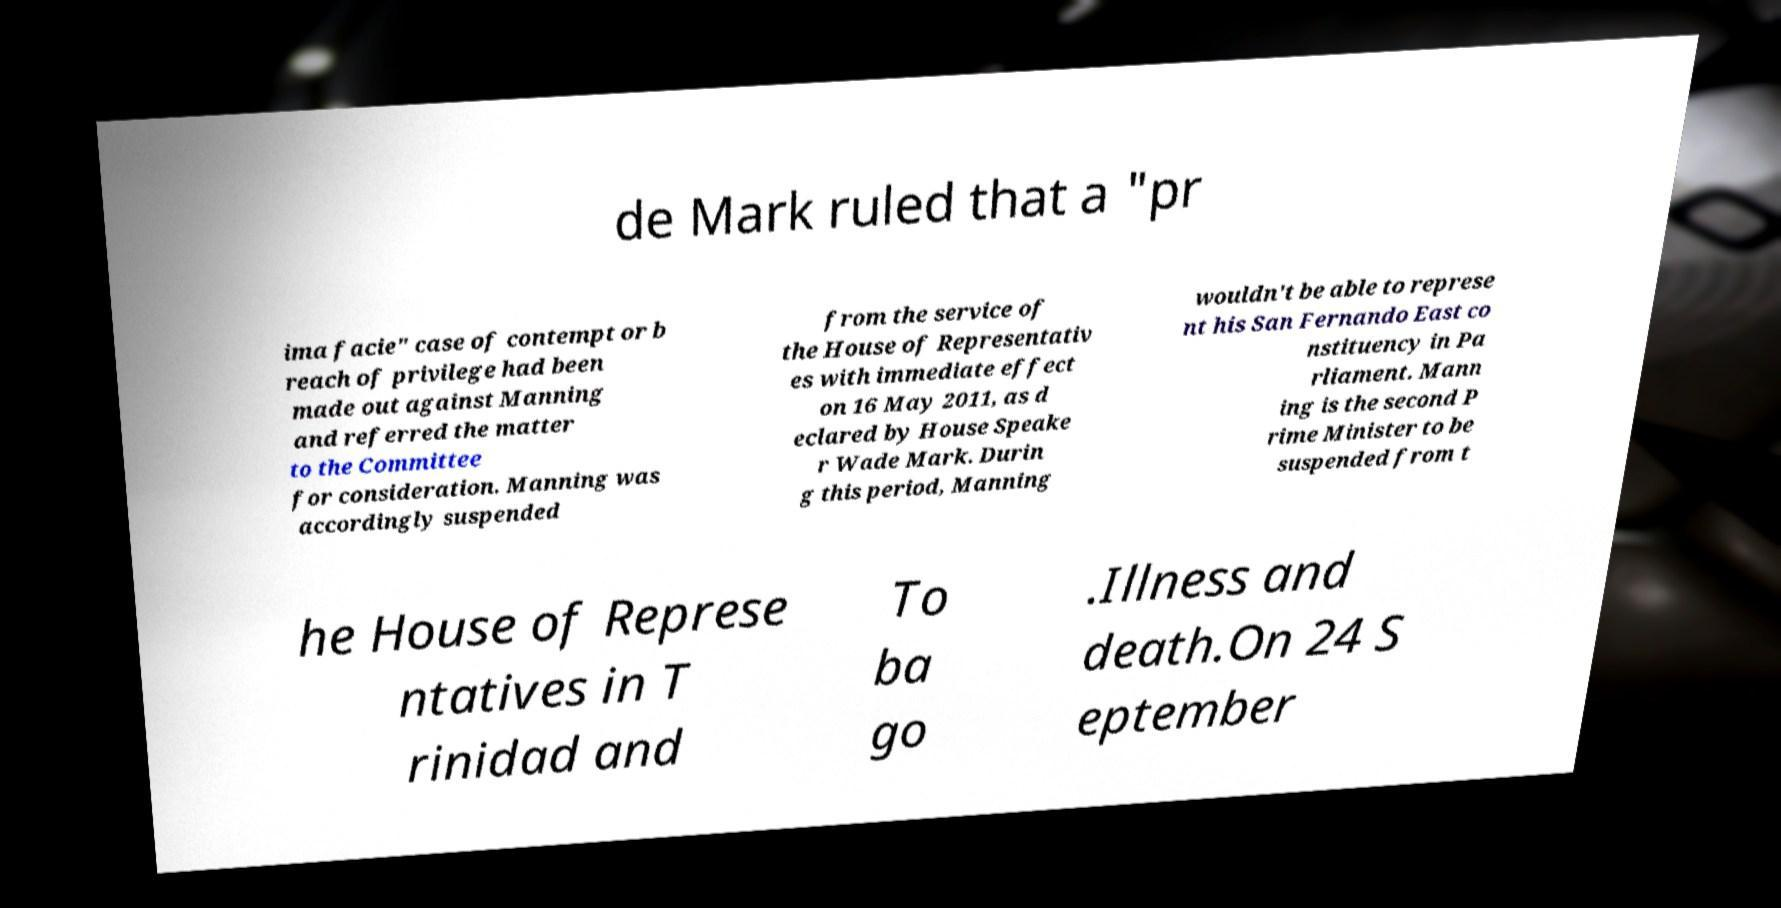What messages or text are displayed in this image? I need them in a readable, typed format. de Mark ruled that a "pr ima facie" case of contempt or b reach of privilege had been made out against Manning and referred the matter to the Committee for consideration. Manning was accordingly suspended from the service of the House of Representativ es with immediate effect on 16 May 2011, as d eclared by House Speake r Wade Mark. Durin g this period, Manning wouldn't be able to represe nt his San Fernando East co nstituency in Pa rliament. Mann ing is the second P rime Minister to be suspended from t he House of Represe ntatives in T rinidad and To ba go .Illness and death.On 24 S eptember 